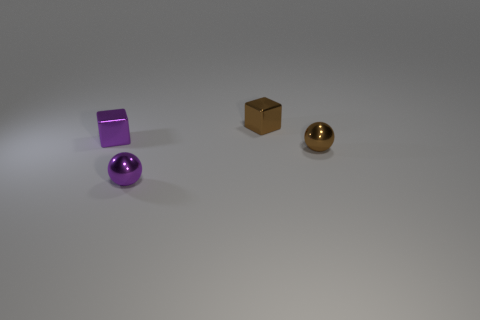Add 1 tiny gray metallic objects. How many objects exist? 5 Subtract all brown blocks. Subtract all big blue balls. How many objects are left? 3 Add 1 tiny purple things. How many tiny purple things are left? 3 Add 3 tiny objects. How many tiny objects exist? 7 Subtract 1 brown cubes. How many objects are left? 3 